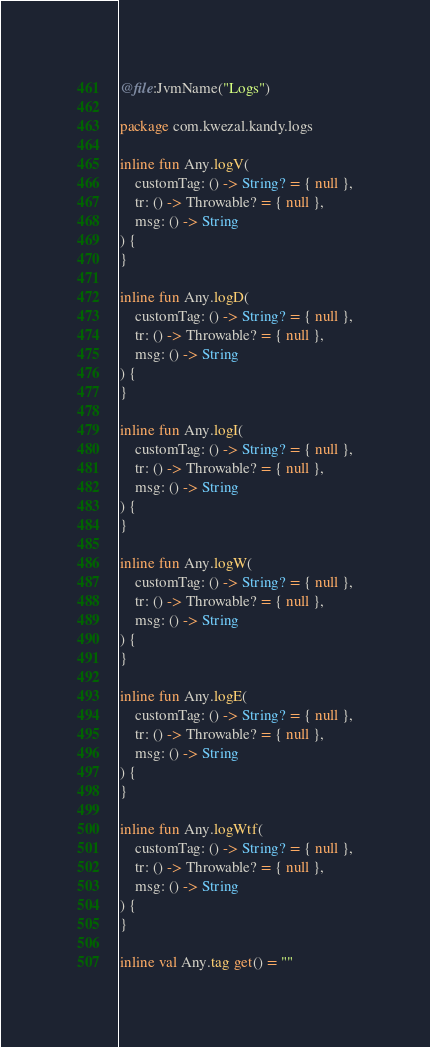Convert code to text. <code><loc_0><loc_0><loc_500><loc_500><_Kotlin_>@file:JvmName("Logs")

package com.kwezal.kandy.logs

inline fun Any.logV(
    customTag: () -> String? = { null },
    tr: () -> Throwable? = { null },
    msg: () -> String
) {
}

inline fun Any.logD(
    customTag: () -> String? = { null },
    tr: () -> Throwable? = { null },
    msg: () -> String
) {
}

inline fun Any.logI(
    customTag: () -> String? = { null },
    tr: () -> Throwable? = { null },
    msg: () -> String
) {
}

inline fun Any.logW(
    customTag: () -> String? = { null },
    tr: () -> Throwable? = { null },
    msg: () -> String
) {
}

inline fun Any.logE(
    customTag: () -> String? = { null },
    tr: () -> Throwable? = { null },
    msg: () -> String
) {
}

inline fun Any.logWtf(
    customTag: () -> String? = { null },
    tr: () -> Throwable? = { null },
    msg: () -> String
) {
}

inline val Any.tag get() = ""</code> 